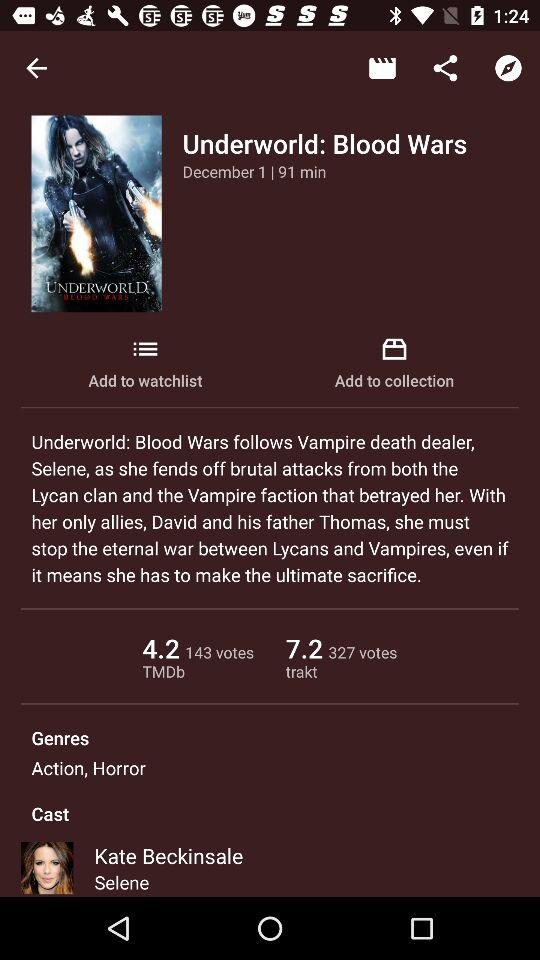What is the total count of votes in TMDb? The total count of votes in TMDb is 143. 